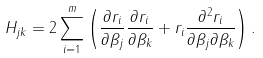Convert formula to latex. <formula><loc_0><loc_0><loc_500><loc_500>H _ { j k } = 2 \sum _ { i = 1 } ^ { m } \left ( { \frac { \partial r _ { i } } { \partial \beta _ { j } } } { \frac { \partial r _ { i } } { \partial \beta _ { k } } } + r _ { i } { \frac { \partial ^ { 2 } r _ { i } } { \partial \beta _ { j } \partial \beta _ { k } } } \right ) .</formula> 